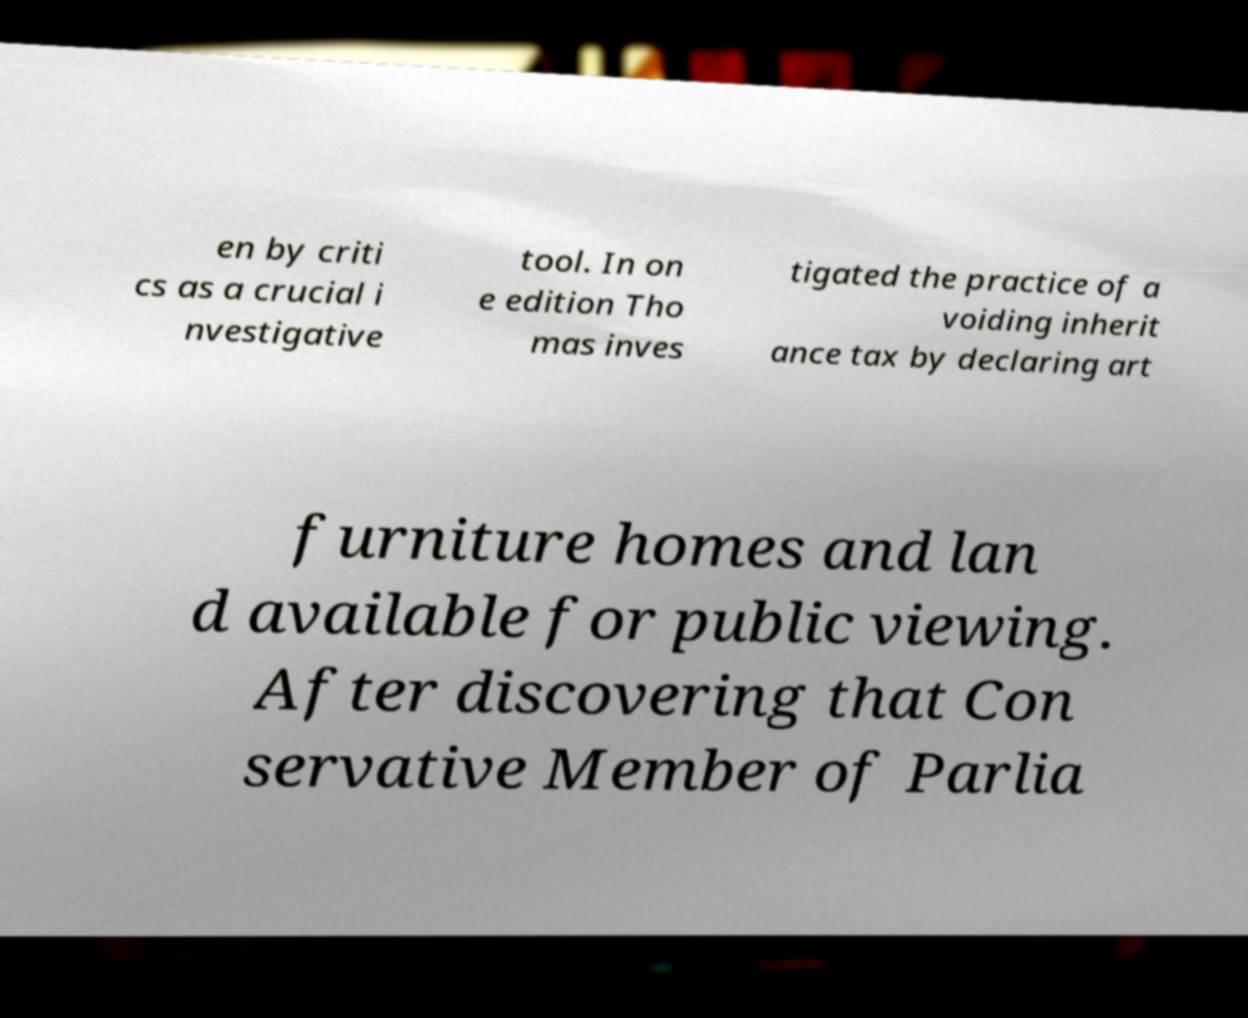There's text embedded in this image that I need extracted. Can you transcribe it verbatim? en by criti cs as a crucial i nvestigative tool. In on e edition Tho mas inves tigated the practice of a voiding inherit ance tax by declaring art furniture homes and lan d available for public viewing. After discovering that Con servative Member of Parlia 